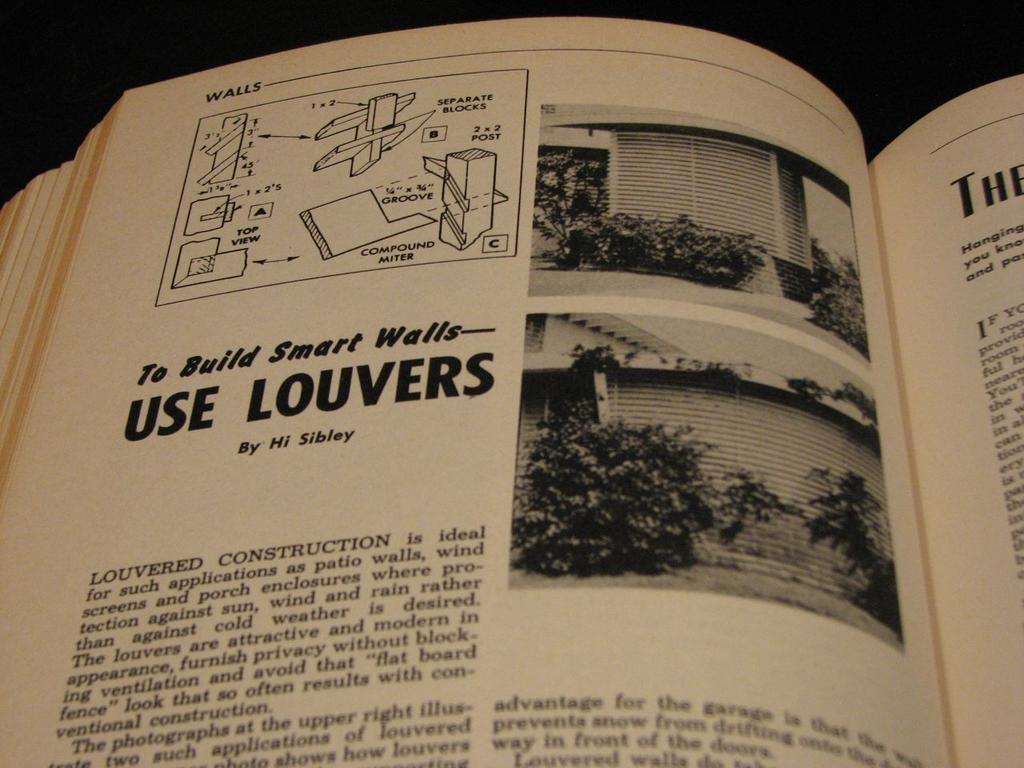<image>
Present a compact description of the photo's key features. the word use is on the page of the book 